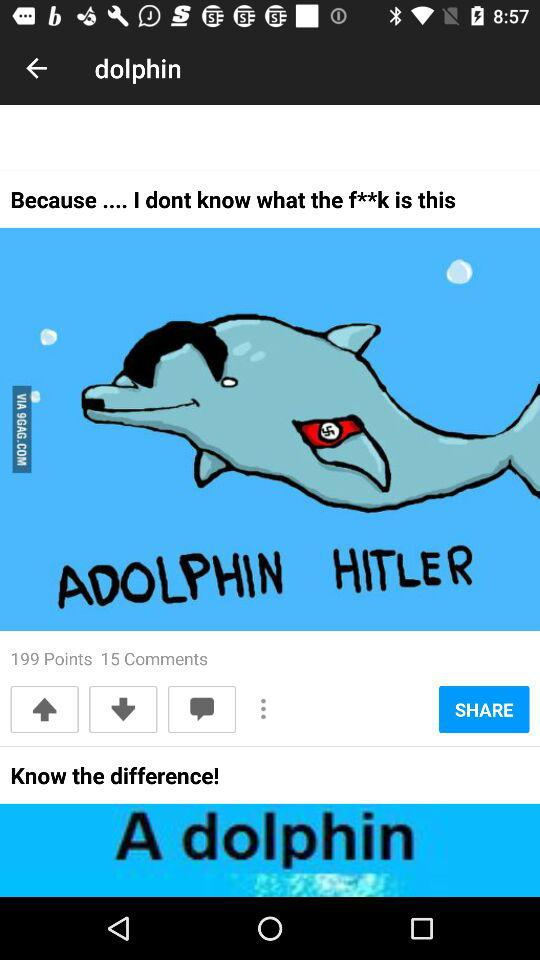How many more points does this post have than comments?
Answer the question using a single word or phrase. 184 